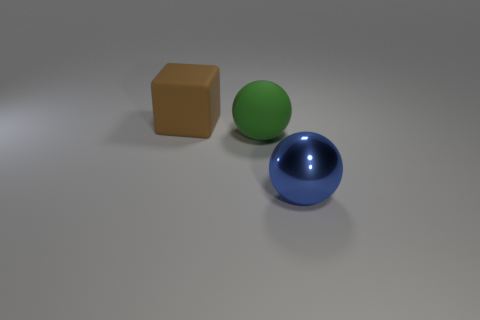Subtract all green spheres. Subtract all gray blocks. How many spheres are left? 1 Add 3 big gray objects. How many objects exist? 6 Subtract all spheres. How many objects are left? 1 Subtract all small blue metal cylinders. Subtract all big green objects. How many objects are left? 2 Add 3 big rubber spheres. How many big rubber spheres are left? 4 Add 3 large green cylinders. How many large green cylinders exist? 3 Subtract 0 green cubes. How many objects are left? 3 